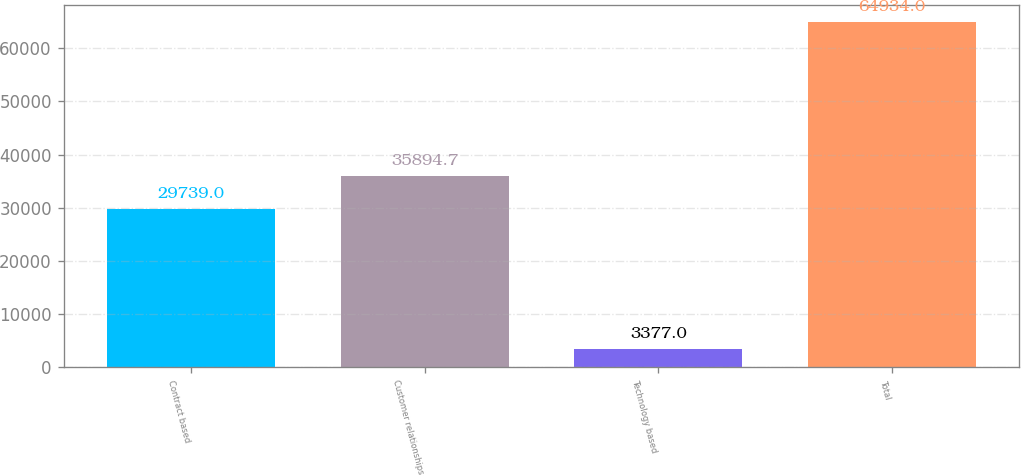<chart> <loc_0><loc_0><loc_500><loc_500><bar_chart><fcel>Contract based<fcel>Customer relationships<fcel>Technology based<fcel>Total<nl><fcel>29739<fcel>35894.7<fcel>3377<fcel>64934<nl></chart> 